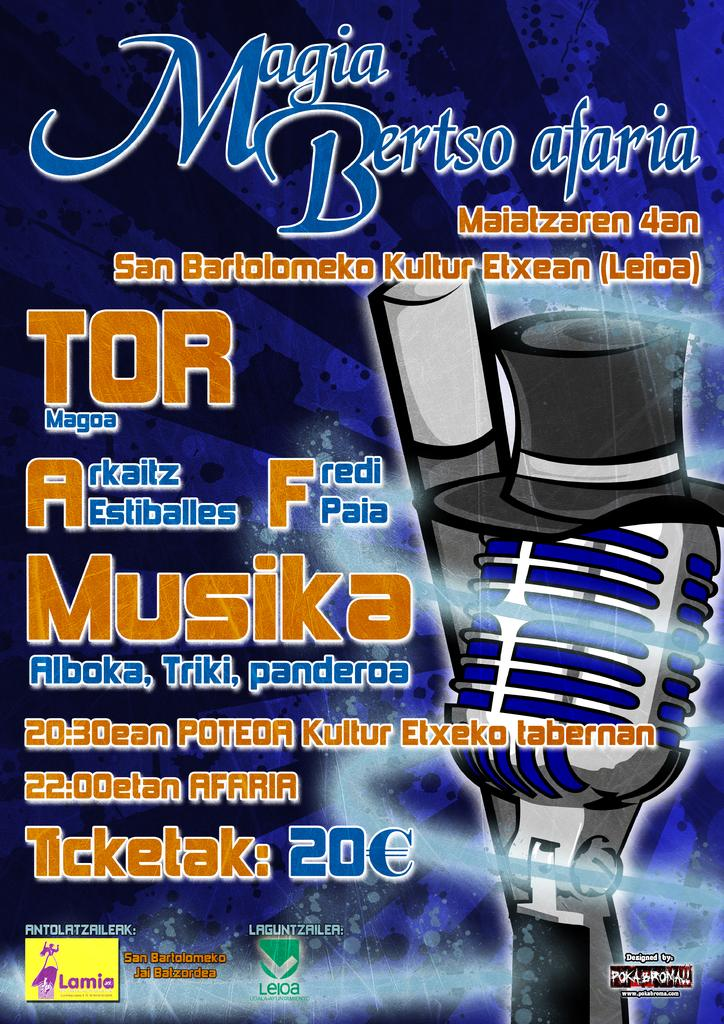<image>
Give a short and clear explanation of the subsequent image. A blue poster for a music festival with a blue microphone. 